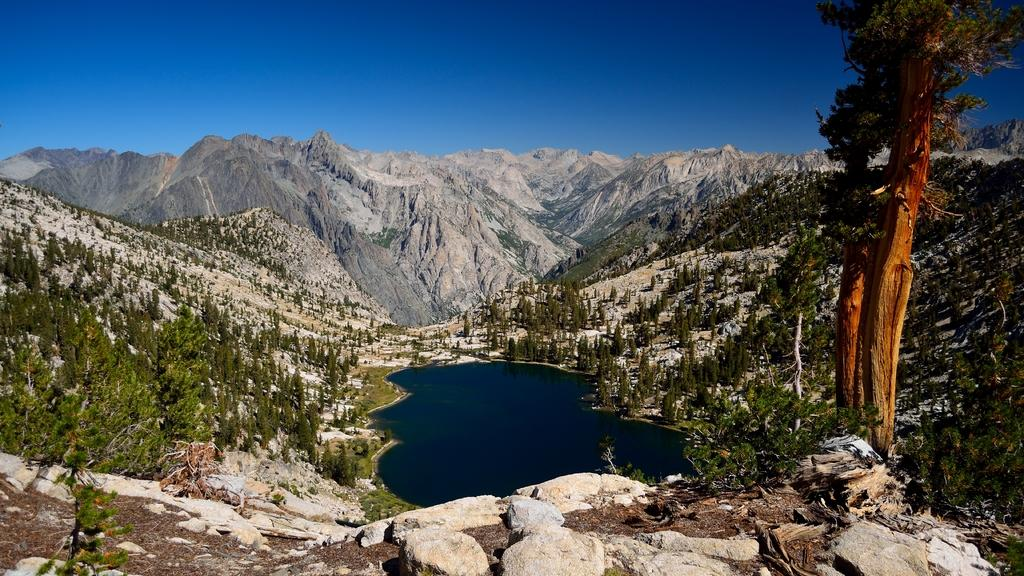What type of natural elements can be seen in the image? There are stones, trees, and water visible in the image. What type of landscape feature is present in the image? There are hills in the image. What part of the natural environment is visible in the image? The sky is visible in the image. What type of tool is being used to fix the hall in the image? There is no hall or tool present in the image. What kind of trouble can be seen in the image? There is no trouble or indication of any problem in the image. 